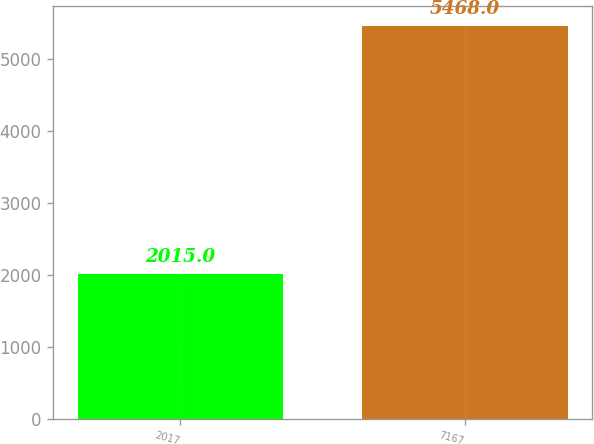Convert chart. <chart><loc_0><loc_0><loc_500><loc_500><bar_chart><fcel>2017<fcel>7167<nl><fcel>2015<fcel>5468<nl></chart> 